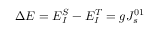<formula> <loc_0><loc_0><loc_500><loc_500>\Delta E = E _ { I } ^ { S } - E _ { I } ^ { T } = g J _ { s } ^ { 0 1 }</formula> 